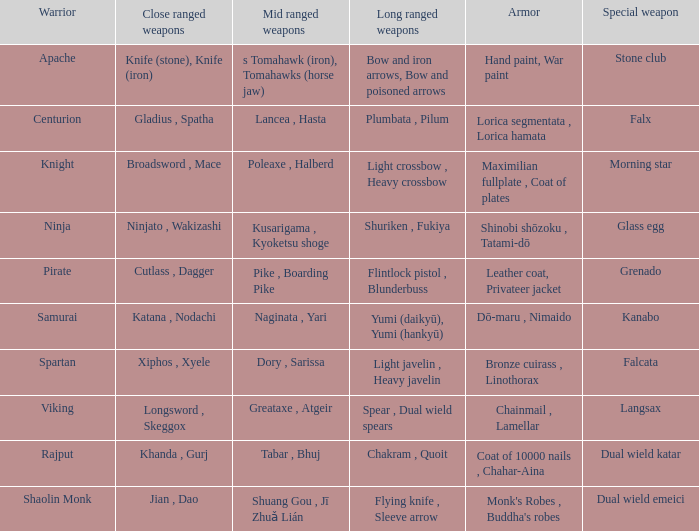If the special weapon is the Grenado, what is the armor? Leather coat, Privateer jacket. 